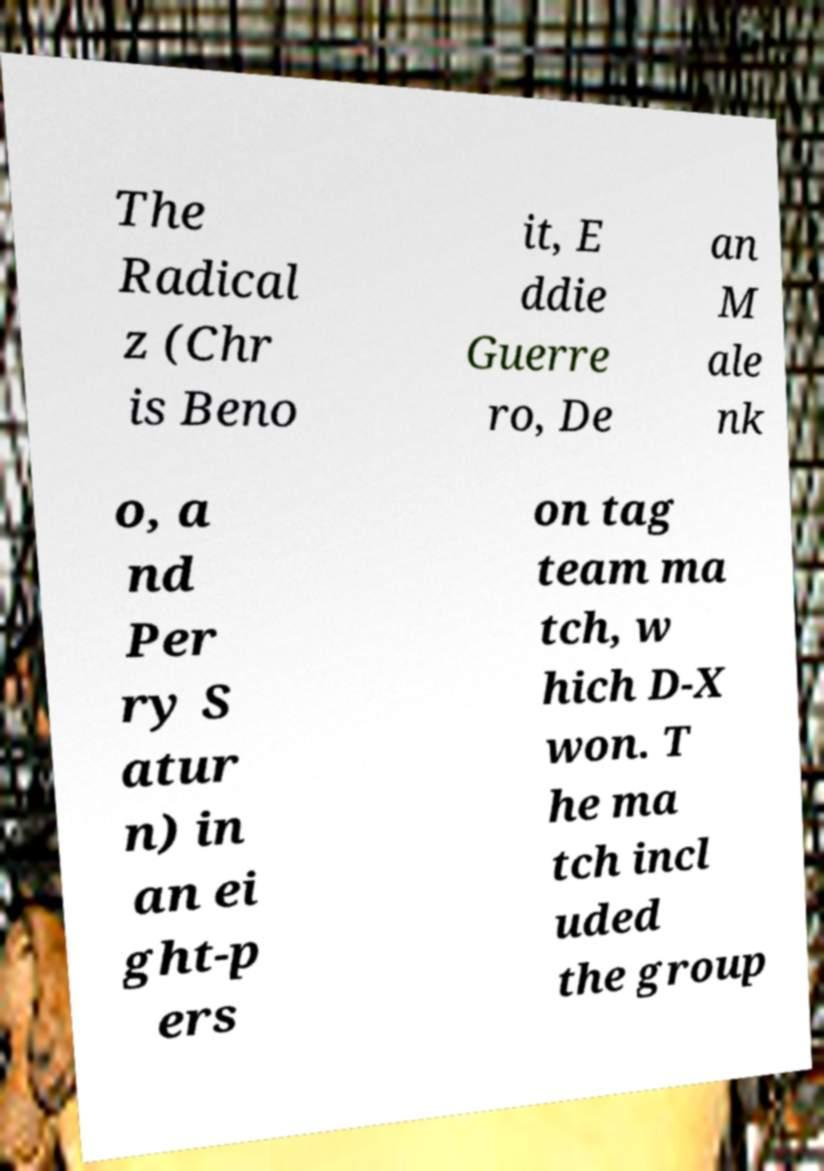Please identify and transcribe the text found in this image. The Radical z (Chr is Beno it, E ddie Guerre ro, De an M ale nk o, a nd Per ry S atur n) in an ei ght-p ers on tag team ma tch, w hich D-X won. T he ma tch incl uded the group 